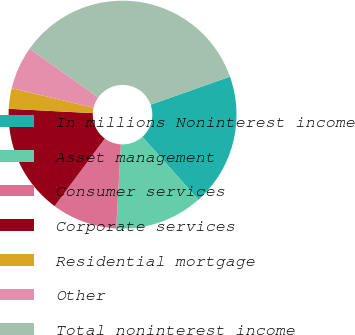Convert chart to OTSL. <chart><loc_0><loc_0><loc_500><loc_500><pie_chart><fcel>In millions Noninterest income<fcel>Asset management<fcel>Consumer services<fcel>Corporate services<fcel>Residential mortgage<fcel>Other<fcel>Total noninterest income<nl><fcel>18.84%<fcel>12.47%<fcel>9.28%<fcel>15.65%<fcel>2.91%<fcel>6.1%<fcel>34.76%<nl></chart> 